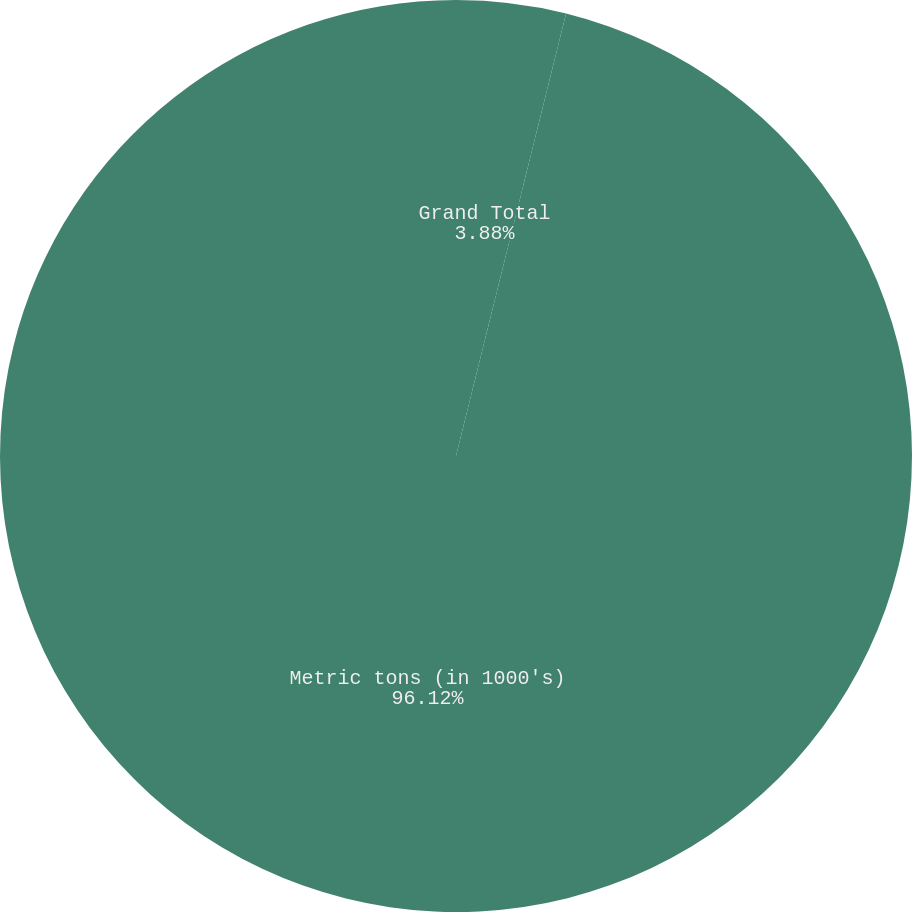Convert chart to OTSL. <chart><loc_0><loc_0><loc_500><loc_500><pie_chart><fcel>Grand Total<fcel>Metric tons (in 1000's)<nl><fcel>3.88%<fcel>96.12%<nl></chart> 